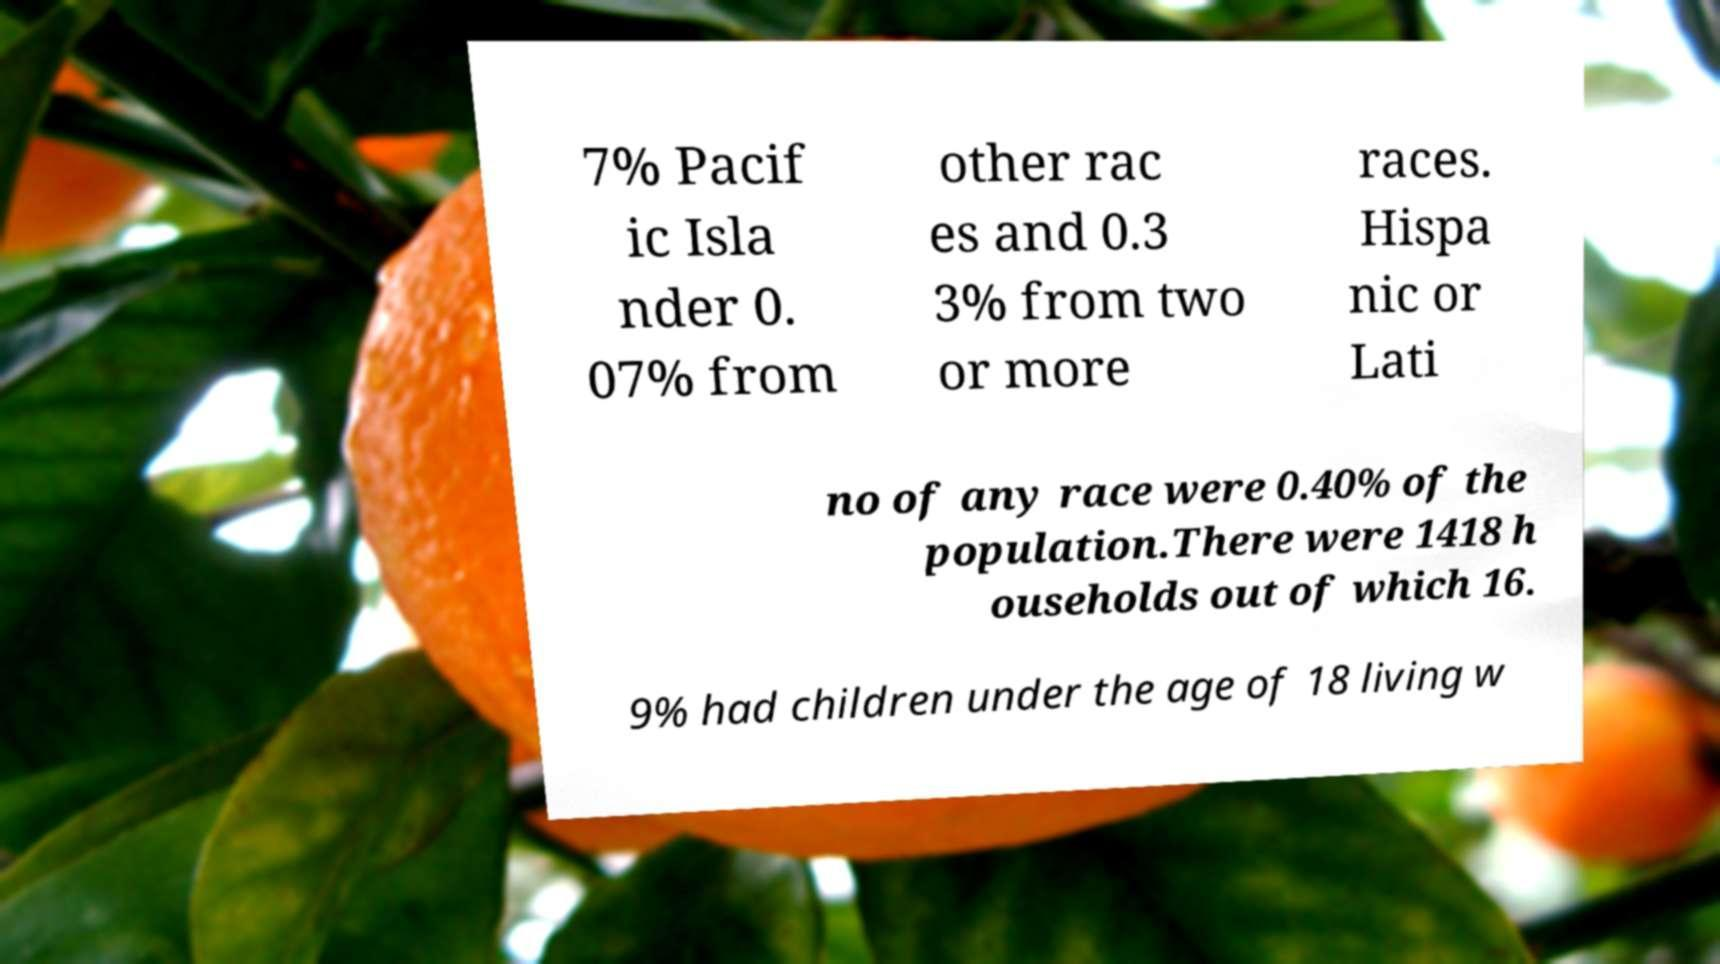What messages or text are displayed in this image? I need them in a readable, typed format. 7% Pacif ic Isla nder 0. 07% from other rac es and 0.3 3% from two or more races. Hispa nic or Lati no of any race were 0.40% of the population.There were 1418 h ouseholds out of which 16. 9% had children under the age of 18 living w 